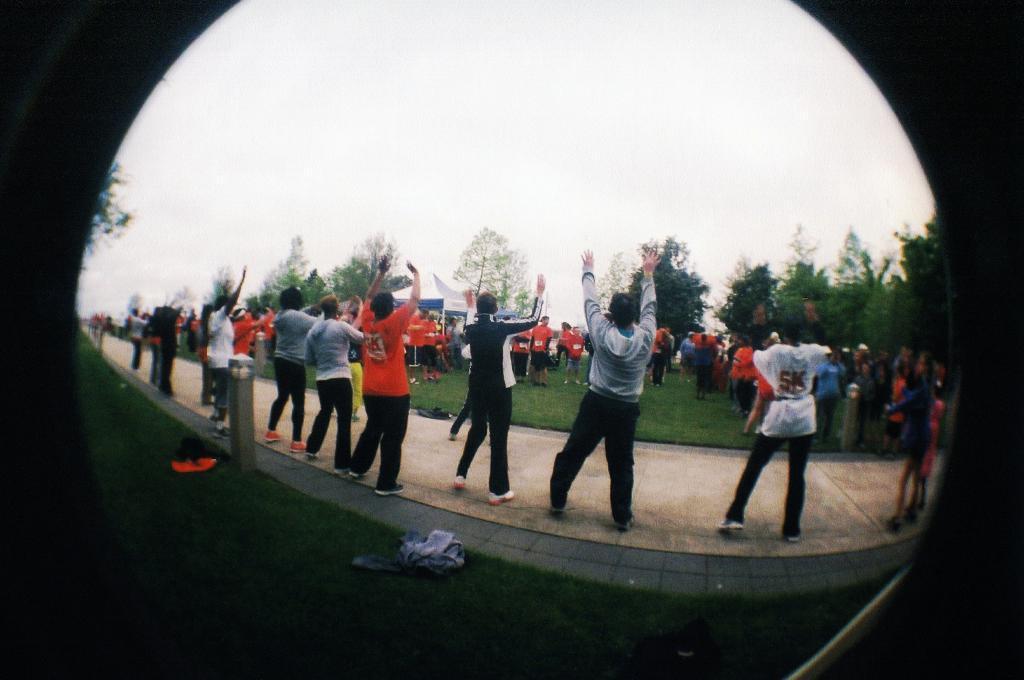How would you summarize this image in a sentence or two? In this image we can see few people standing on the road and few people standing on the grass, there are few objects looks like clothes and and an iron rod behind the people and in the background there are objects looks like banners and trees and the sky. 